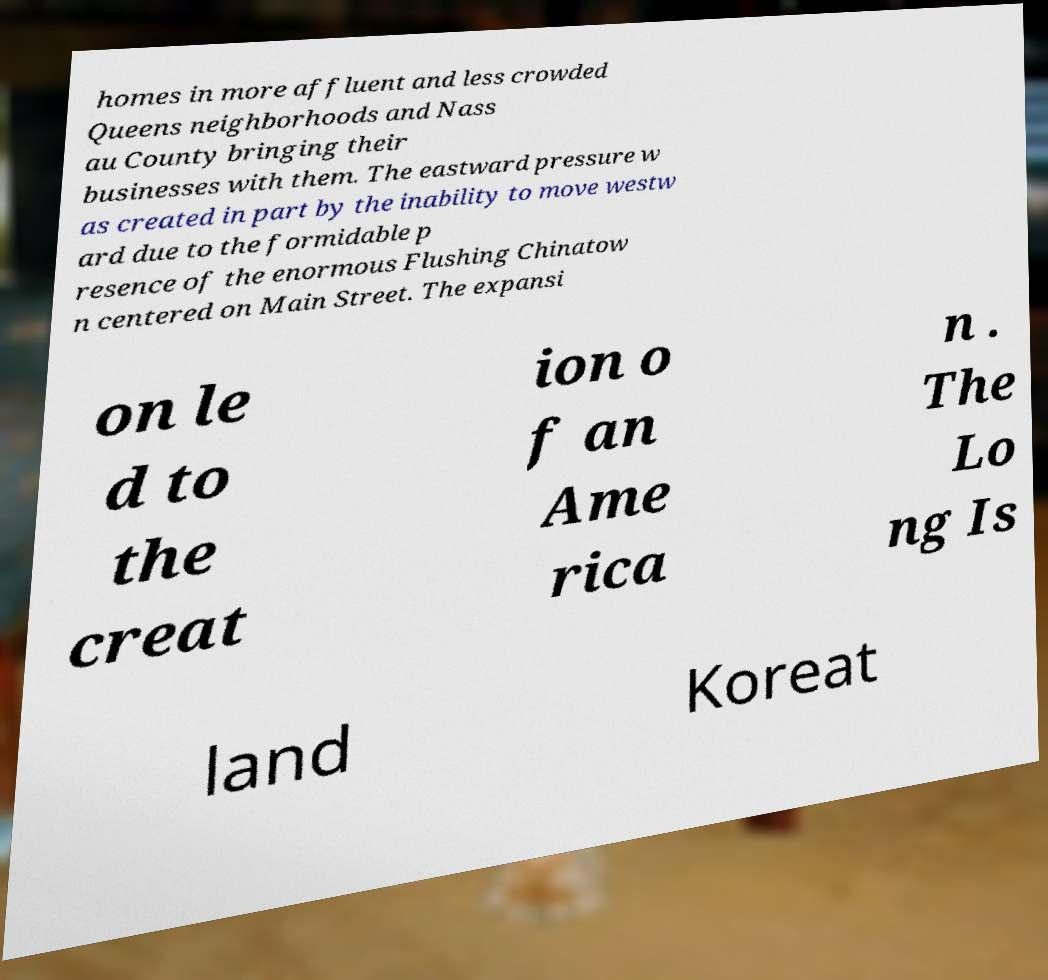Please identify and transcribe the text found in this image. homes in more affluent and less crowded Queens neighborhoods and Nass au County bringing their businesses with them. The eastward pressure w as created in part by the inability to move westw ard due to the formidable p resence of the enormous Flushing Chinatow n centered on Main Street. The expansi on le d to the creat ion o f an Ame rica n . The Lo ng Is land Koreat 